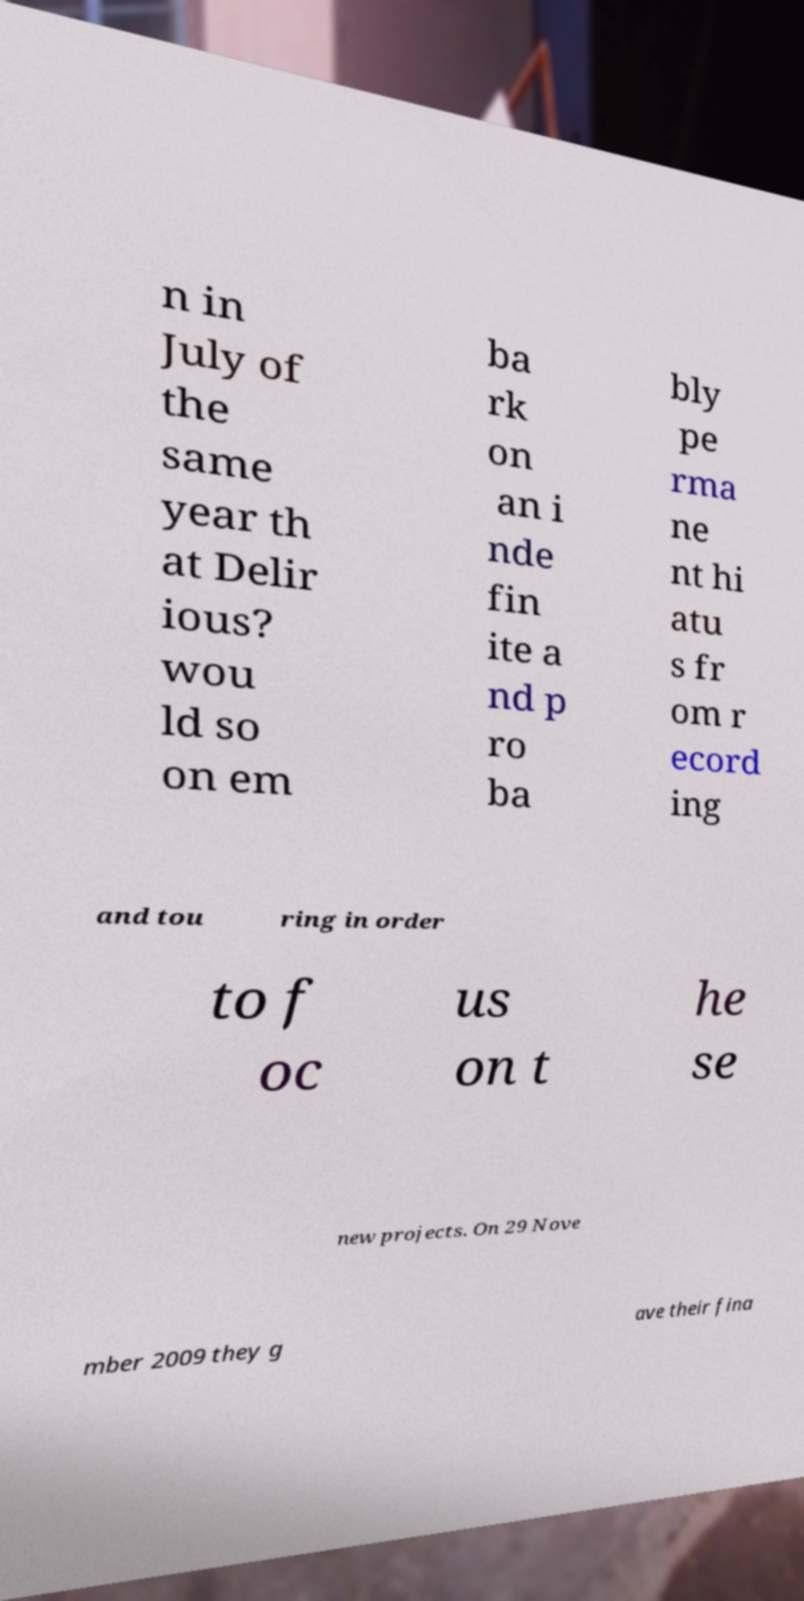Can you read and provide the text displayed in the image?This photo seems to have some interesting text. Can you extract and type it out for me? n in July of the same year th at Delir ious? wou ld so on em ba rk on an i nde fin ite a nd p ro ba bly pe rma ne nt hi atu s fr om r ecord ing and tou ring in order to f oc us on t he se new projects. On 29 Nove mber 2009 they g ave their fina 